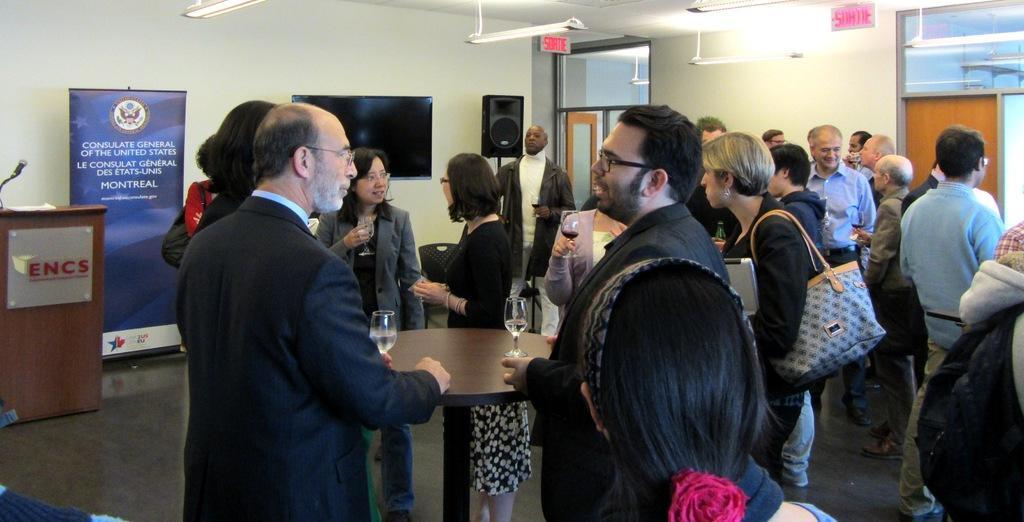In one or two sentences, can you explain what this image depicts? In this image we can see people standing on the floor and some of them are holding beverage glasses in their hands. In the background we can see podium and a mic attached to it, advertisement board, television, speaker, doors, sign board, side table, chairs and walls. 